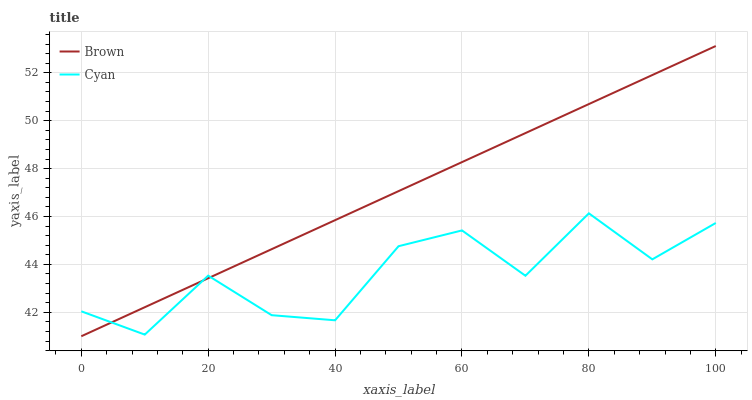Does Cyan have the maximum area under the curve?
Answer yes or no. No. Is Cyan the smoothest?
Answer yes or no. No. Does Cyan have the lowest value?
Answer yes or no. No. Does Cyan have the highest value?
Answer yes or no. No. 